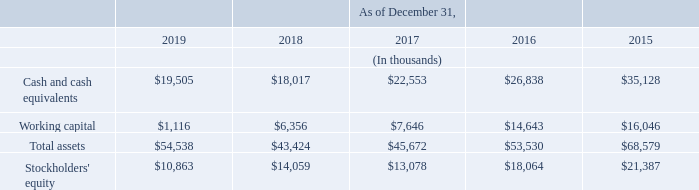Item 6. Selected Consolidated Financial Data
The following table presents selected consolidated financial data as of and for the five-year period ended December 31, 2019. Our past results of operations are not necessarily indicative of our future results of operations. The following selected consolidated financial data is qualified in its entirety by, and should be read in conjunction with, “Management's Discussion and Analysis of Financial Condition and Results of Operations” and the consolidated financial statements and the notes thereto included elsewhere herein.
Consolidated Balance Sheet Data:
What is the value of cash and cash equivalents from 2019 to 2015 respectively?
Answer scale should be: thousand. $19,505, $18,017, $22,553, $26,838, $35,128. What is the value of working capital from 2019 to 2015 respectively?
Answer scale should be: thousand. $1,116, $6,356, $7,646, $14,643, $16,046. What should the table show be read in conjunction with? Management's discussion and analysis of financial condition and results of operations” and the consolidated financial statements and the notes thereto included elsewhere herein. What is the average value of working capital from 2015 to 2019?
Answer scale should be: thousand. (1,116+ 6,356+ 7,646+ 14,643+16,046)/5
Answer: 9161.4. What is the change in the value of total assets between 2019 and 2018?
Answer scale should be: thousand. 54,538-43,424
Answer: 11114. What is the percentage change for cash and cash equivalents between 2018 and 2019?
Answer scale should be: percent. (19,505-18,017)/18,017
Answer: 8.26. 